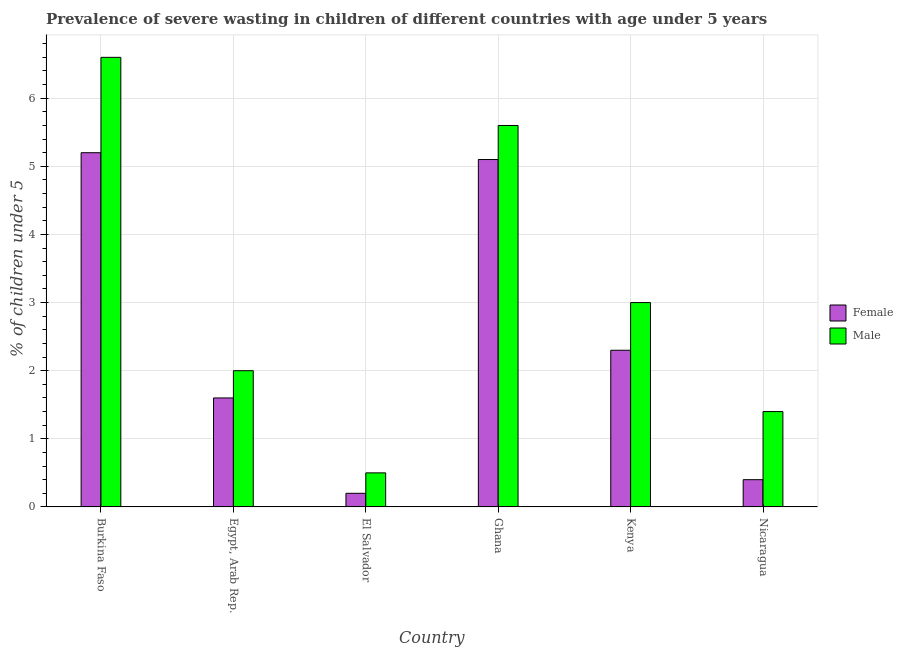How many different coloured bars are there?
Keep it short and to the point. 2. How many groups of bars are there?
Make the answer very short. 6. How many bars are there on the 1st tick from the left?
Give a very brief answer. 2. How many bars are there on the 2nd tick from the right?
Your answer should be compact. 2. What is the label of the 2nd group of bars from the left?
Your answer should be compact. Egypt, Arab Rep. In how many cases, is the number of bars for a given country not equal to the number of legend labels?
Ensure brevity in your answer.  0. What is the percentage of undernourished male children in Kenya?
Ensure brevity in your answer.  3. Across all countries, what is the maximum percentage of undernourished female children?
Offer a terse response. 5.2. Across all countries, what is the minimum percentage of undernourished female children?
Offer a terse response. 0.2. In which country was the percentage of undernourished female children maximum?
Your answer should be compact. Burkina Faso. In which country was the percentage of undernourished male children minimum?
Give a very brief answer. El Salvador. What is the total percentage of undernourished female children in the graph?
Provide a short and direct response. 14.8. What is the difference between the percentage of undernourished female children in Egypt, Arab Rep. and that in Ghana?
Offer a terse response. -3.5. What is the difference between the percentage of undernourished female children in Burkina Faso and the percentage of undernourished male children in Nicaragua?
Your answer should be compact. 3.8. What is the average percentage of undernourished male children per country?
Provide a succinct answer. 3.18. What is the difference between the percentage of undernourished male children and percentage of undernourished female children in Kenya?
Ensure brevity in your answer.  0.7. In how many countries, is the percentage of undernourished male children greater than 2.6 %?
Offer a terse response. 3. What is the ratio of the percentage of undernourished male children in El Salvador to that in Kenya?
Offer a very short reply. 0.17. What is the difference between the highest and the lowest percentage of undernourished male children?
Give a very brief answer. 6.1. Is the sum of the percentage of undernourished male children in Burkina Faso and El Salvador greater than the maximum percentage of undernourished female children across all countries?
Your response must be concise. Yes. What does the 1st bar from the left in Burkina Faso represents?
Your answer should be compact. Female. What does the 2nd bar from the right in El Salvador represents?
Offer a very short reply. Female. What is the difference between two consecutive major ticks on the Y-axis?
Make the answer very short. 1. How are the legend labels stacked?
Give a very brief answer. Vertical. What is the title of the graph?
Your answer should be compact. Prevalence of severe wasting in children of different countries with age under 5 years. What is the label or title of the Y-axis?
Offer a very short reply.  % of children under 5. What is the  % of children under 5 of Female in Burkina Faso?
Provide a succinct answer. 5.2. What is the  % of children under 5 of Male in Burkina Faso?
Your answer should be very brief. 6.6. What is the  % of children under 5 of Female in Egypt, Arab Rep.?
Provide a short and direct response. 1.6. What is the  % of children under 5 of Male in Egypt, Arab Rep.?
Your response must be concise. 2. What is the  % of children under 5 in Female in El Salvador?
Offer a very short reply. 0.2. What is the  % of children under 5 in Male in El Salvador?
Ensure brevity in your answer.  0.5. What is the  % of children under 5 in Female in Ghana?
Your response must be concise. 5.1. What is the  % of children under 5 in Male in Ghana?
Your answer should be compact. 5.6. What is the  % of children under 5 in Female in Kenya?
Provide a succinct answer. 2.3. What is the  % of children under 5 in Male in Kenya?
Offer a terse response. 3. What is the  % of children under 5 of Female in Nicaragua?
Provide a short and direct response. 0.4. What is the  % of children under 5 in Male in Nicaragua?
Ensure brevity in your answer.  1.4. Across all countries, what is the maximum  % of children under 5 of Female?
Provide a succinct answer. 5.2. Across all countries, what is the maximum  % of children under 5 in Male?
Offer a terse response. 6.6. Across all countries, what is the minimum  % of children under 5 of Female?
Your response must be concise. 0.2. What is the total  % of children under 5 in Male in the graph?
Provide a succinct answer. 19.1. What is the difference between the  % of children under 5 of Female in Burkina Faso and that in Egypt, Arab Rep.?
Offer a terse response. 3.6. What is the difference between the  % of children under 5 of Female in Burkina Faso and that in Ghana?
Your answer should be very brief. 0.1. What is the difference between the  % of children under 5 of Male in Burkina Faso and that in Ghana?
Keep it short and to the point. 1. What is the difference between the  % of children under 5 in Female in Burkina Faso and that in Kenya?
Provide a short and direct response. 2.9. What is the difference between the  % of children under 5 of Female in Egypt, Arab Rep. and that in El Salvador?
Ensure brevity in your answer.  1.4. What is the difference between the  % of children under 5 in Male in Egypt, Arab Rep. and that in El Salvador?
Provide a succinct answer. 1.5. What is the difference between the  % of children under 5 of Female in Egypt, Arab Rep. and that in Ghana?
Offer a terse response. -3.5. What is the difference between the  % of children under 5 of Male in Egypt, Arab Rep. and that in Ghana?
Your answer should be very brief. -3.6. What is the difference between the  % of children under 5 in Male in Egypt, Arab Rep. and that in Kenya?
Ensure brevity in your answer.  -1. What is the difference between the  % of children under 5 in Female in Egypt, Arab Rep. and that in Nicaragua?
Give a very brief answer. 1.2. What is the difference between the  % of children under 5 of Male in Egypt, Arab Rep. and that in Nicaragua?
Your answer should be very brief. 0.6. What is the difference between the  % of children under 5 in Male in El Salvador and that in Kenya?
Offer a terse response. -2.5. What is the difference between the  % of children under 5 in Female in El Salvador and that in Nicaragua?
Keep it short and to the point. -0.2. What is the difference between the  % of children under 5 in Female in Ghana and that in Kenya?
Provide a succinct answer. 2.8. What is the difference between the  % of children under 5 in Female in Ghana and that in Nicaragua?
Your answer should be compact. 4.7. What is the difference between the  % of children under 5 of Female in Kenya and that in Nicaragua?
Offer a very short reply. 1.9. What is the difference between the  % of children under 5 in Female in Burkina Faso and the  % of children under 5 in Male in Egypt, Arab Rep.?
Your answer should be very brief. 3.2. What is the difference between the  % of children under 5 in Female in Burkina Faso and the  % of children under 5 in Male in El Salvador?
Keep it short and to the point. 4.7. What is the difference between the  % of children under 5 in Female in Burkina Faso and the  % of children under 5 in Male in Ghana?
Offer a very short reply. -0.4. What is the difference between the  % of children under 5 of Female in Burkina Faso and the  % of children under 5 of Male in Nicaragua?
Offer a very short reply. 3.8. What is the difference between the  % of children under 5 in Female in Egypt, Arab Rep. and the  % of children under 5 in Male in Ghana?
Give a very brief answer. -4. What is the difference between the  % of children under 5 of Female in Egypt, Arab Rep. and the  % of children under 5 of Male in Kenya?
Provide a short and direct response. -1.4. What is the difference between the  % of children under 5 in Female in El Salvador and the  % of children under 5 in Male in Ghana?
Give a very brief answer. -5.4. What is the difference between the  % of children under 5 in Female in El Salvador and the  % of children under 5 in Male in Kenya?
Provide a succinct answer. -2.8. What is the difference between the  % of children under 5 in Female in El Salvador and the  % of children under 5 in Male in Nicaragua?
Ensure brevity in your answer.  -1.2. What is the difference between the  % of children under 5 of Female in Kenya and the  % of children under 5 of Male in Nicaragua?
Your answer should be very brief. 0.9. What is the average  % of children under 5 in Female per country?
Your answer should be compact. 2.47. What is the average  % of children under 5 in Male per country?
Provide a short and direct response. 3.18. What is the difference between the  % of children under 5 in Female and  % of children under 5 in Male in Egypt, Arab Rep.?
Offer a very short reply. -0.4. What is the difference between the  % of children under 5 of Female and  % of children under 5 of Male in Ghana?
Make the answer very short. -0.5. What is the difference between the  % of children under 5 in Female and  % of children under 5 in Male in Kenya?
Keep it short and to the point. -0.7. What is the difference between the  % of children under 5 of Female and  % of children under 5 of Male in Nicaragua?
Give a very brief answer. -1. What is the ratio of the  % of children under 5 of Female in Burkina Faso to that in Egypt, Arab Rep.?
Your answer should be compact. 3.25. What is the ratio of the  % of children under 5 in Male in Burkina Faso to that in Egypt, Arab Rep.?
Offer a terse response. 3.3. What is the ratio of the  % of children under 5 in Female in Burkina Faso to that in El Salvador?
Give a very brief answer. 26. What is the ratio of the  % of children under 5 in Female in Burkina Faso to that in Ghana?
Your answer should be very brief. 1.02. What is the ratio of the  % of children under 5 of Male in Burkina Faso to that in Ghana?
Ensure brevity in your answer.  1.18. What is the ratio of the  % of children under 5 of Female in Burkina Faso to that in Kenya?
Your answer should be very brief. 2.26. What is the ratio of the  % of children under 5 in Male in Burkina Faso to that in Nicaragua?
Make the answer very short. 4.71. What is the ratio of the  % of children under 5 in Female in Egypt, Arab Rep. to that in El Salvador?
Ensure brevity in your answer.  8. What is the ratio of the  % of children under 5 in Male in Egypt, Arab Rep. to that in El Salvador?
Keep it short and to the point. 4. What is the ratio of the  % of children under 5 of Female in Egypt, Arab Rep. to that in Ghana?
Your answer should be compact. 0.31. What is the ratio of the  % of children under 5 of Male in Egypt, Arab Rep. to that in Ghana?
Provide a short and direct response. 0.36. What is the ratio of the  % of children under 5 of Female in Egypt, Arab Rep. to that in Kenya?
Keep it short and to the point. 0.7. What is the ratio of the  % of children under 5 in Male in Egypt, Arab Rep. to that in Kenya?
Give a very brief answer. 0.67. What is the ratio of the  % of children under 5 of Female in Egypt, Arab Rep. to that in Nicaragua?
Offer a very short reply. 4. What is the ratio of the  % of children under 5 of Male in Egypt, Arab Rep. to that in Nicaragua?
Ensure brevity in your answer.  1.43. What is the ratio of the  % of children under 5 of Female in El Salvador to that in Ghana?
Keep it short and to the point. 0.04. What is the ratio of the  % of children under 5 in Male in El Salvador to that in Ghana?
Keep it short and to the point. 0.09. What is the ratio of the  % of children under 5 of Female in El Salvador to that in Kenya?
Offer a terse response. 0.09. What is the ratio of the  % of children under 5 of Male in El Salvador to that in Nicaragua?
Give a very brief answer. 0.36. What is the ratio of the  % of children under 5 of Female in Ghana to that in Kenya?
Your response must be concise. 2.22. What is the ratio of the  % of children under 5 of Male in Ghana to that in Kenya?
Ensure brevity in your answer.  1.87. What is the ratio of the  % of children under 5 in Female in Ghana to that in Nicaragua?
Give a very brief answer. 12.75. What is the ratio of the  % of children under 5 in Female in Kenya to that in Nicaragua?
Your answer should be compact. 5.75. What is the ratio of the  % of children under 5 in Male in Kenya to that in Nicaragua?
Your response must be concise. 2.14. 